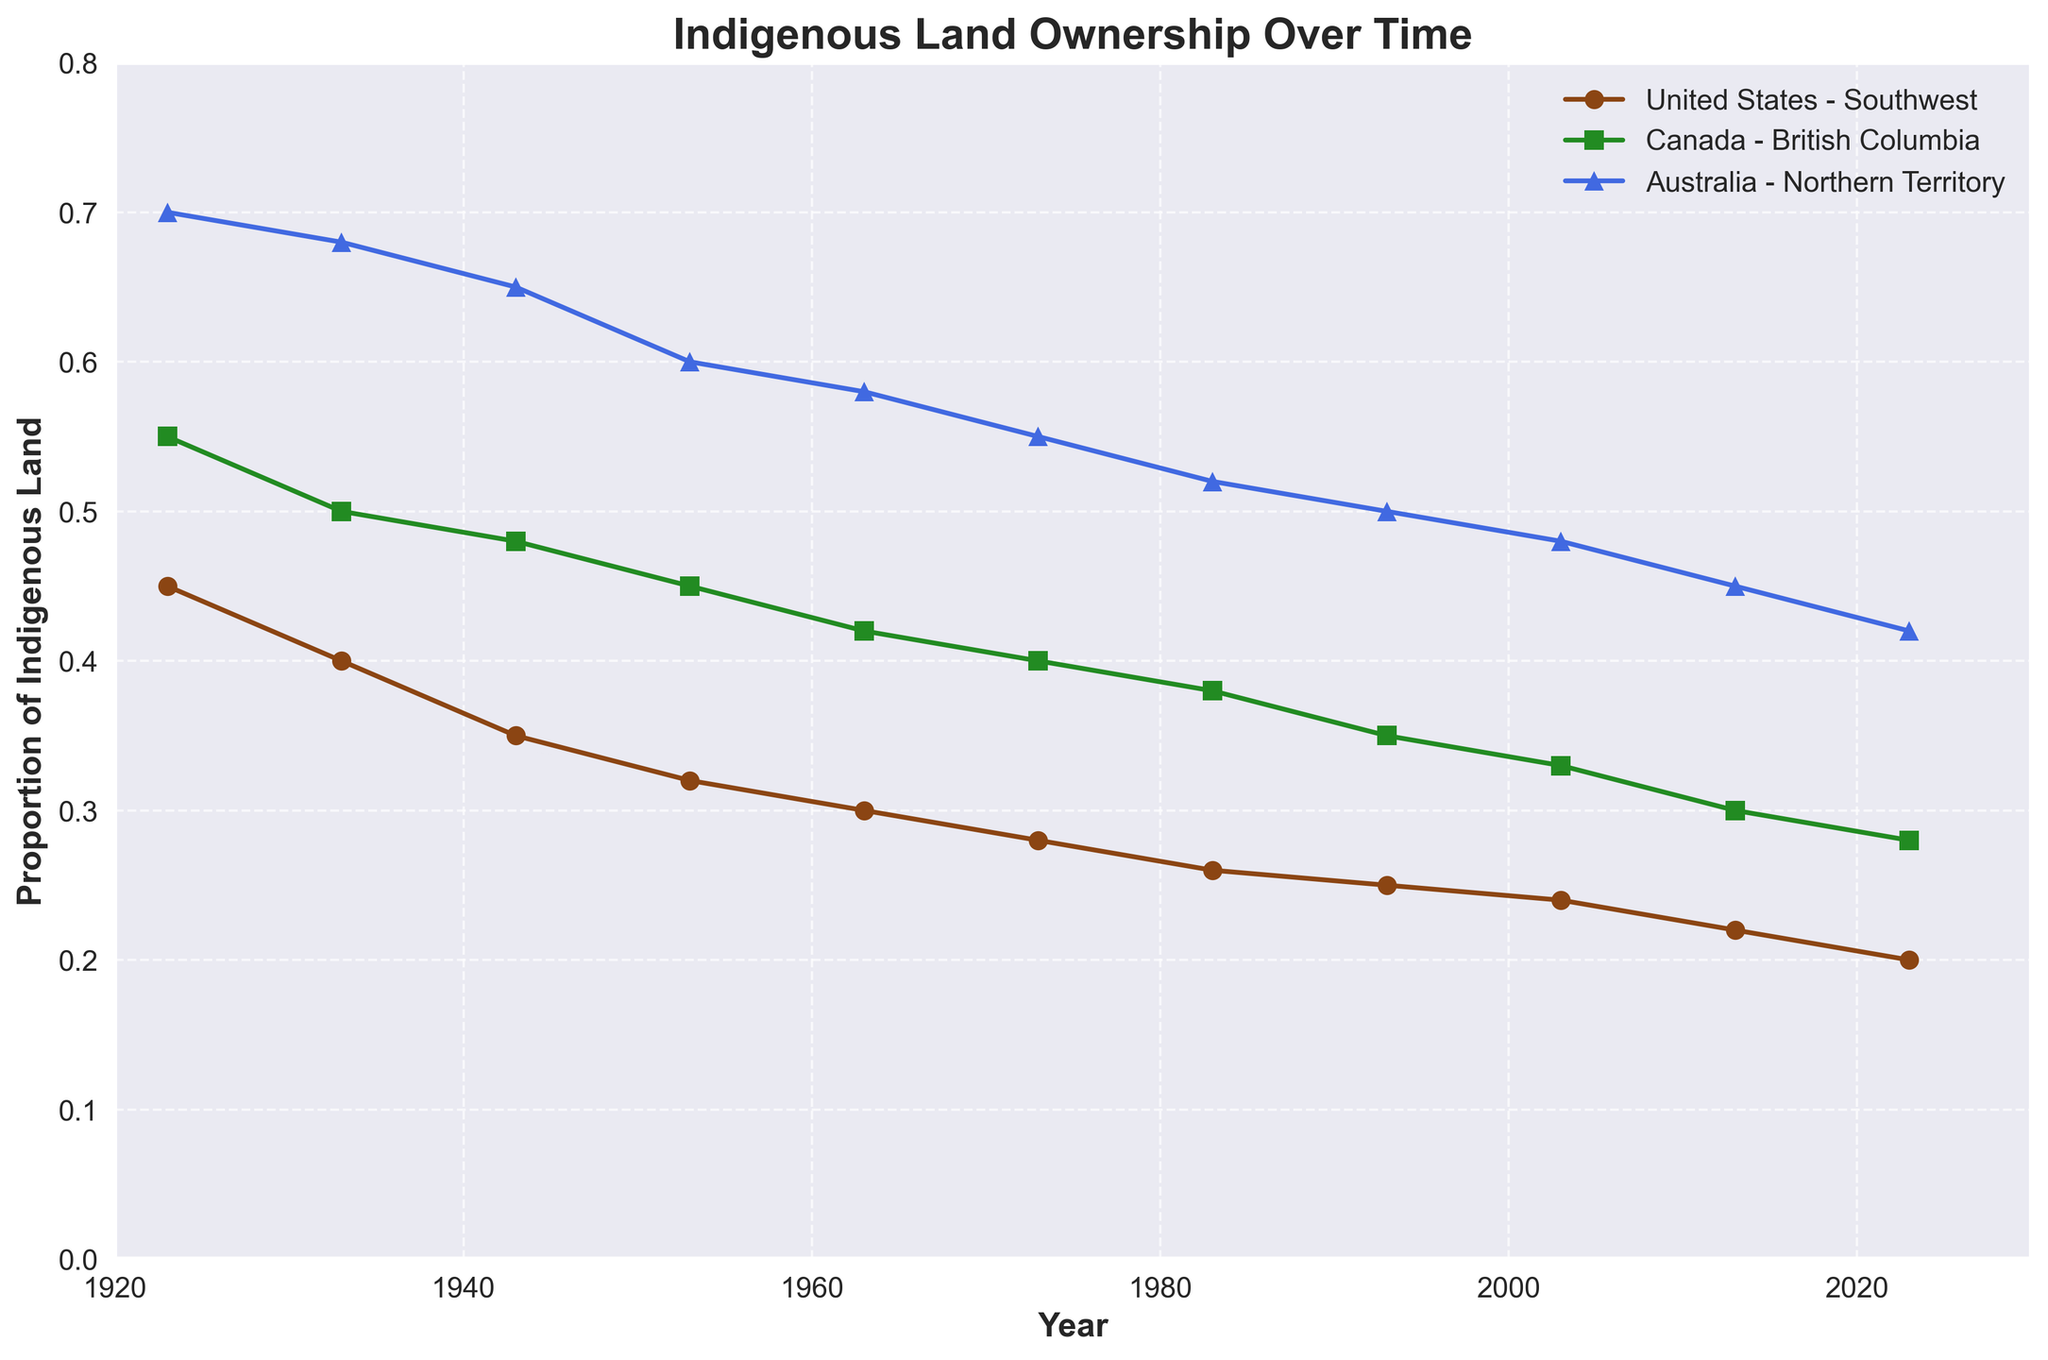what is the title of the plot? The title of the plot is located at the top center of the figure.
Answer: Indigenous Land Ownership Over Time Which region had the highest proportion of land owned by indigenous peoples in 1923? In 1923, you can look at the leftmost points for each region. The highest point among them is for Australia - Northern Territory.
Answer: Australia - Northern Territory How did the proportion of land owned by indigenous peoples change in the Southwest United States between 1923 and 2023? Look at the Southwest United States line from the beginning (1923) to the end (2023). The proportion decreased from 0.45 to 0.20.
Answer: Decreased from 0.45 to 0.20 In which period did the Northern Territory in Australia see the largest decline in the proportion of land owned by indigenous peoples? Compare the slopes (steepness) of the line segments for the Northern Territory between consecutive decades. The largest decline occurs between 1943 and 1953.
Answer: 1943 to 1953 What is the difference in the proportion of land owned by indigenous peoples in British Columbia, Canada, in 1923 and 2023? Subtract the proportion in 1923 from the proportion in 2023 for British Columbia. 0.55 - 0.28 = 0.27.
Answer: 0.27 Which country maintained a higher proportion of land ownership by indigenous peoples throughout the century, Canada or the United States? Compare the lines for Canada (British Columbia) and the United States (Southwest). The line for Canada is consistently higher than the line for the United States.
Answer: Canada What trend is observed regarding the proportion of land owned by indigenous peoples in the dataset? Observe the overall movement of the lines for all regions. All lines show a decreasing trend over the century.
Answer: Decreasing trend Between 1983 and 2003, which region saw the smallest decrease in land owned by indigenous peoples? Compare the decrements in proportions between 1983 and 2003 for all regions by looking at their respective lines. British Columbia decreases from 0.38 to 0.33, which is smaller compared to others.
Answer: British Columbia What is the approximate average proportion of land owned by indigenous peoples in Northern Territory, Australia, over the century? Sum the proportions for each decade for Northern Territory and divide by the total number of data points (11). (0.70 + 0.68 + 0.65 + 0.60 + 0.58 + 0.55 + 0.52 + 0.50 + 0.48 + 0.45 + 0.42) / 11 ≈ 0.564
Answer: 0.564 